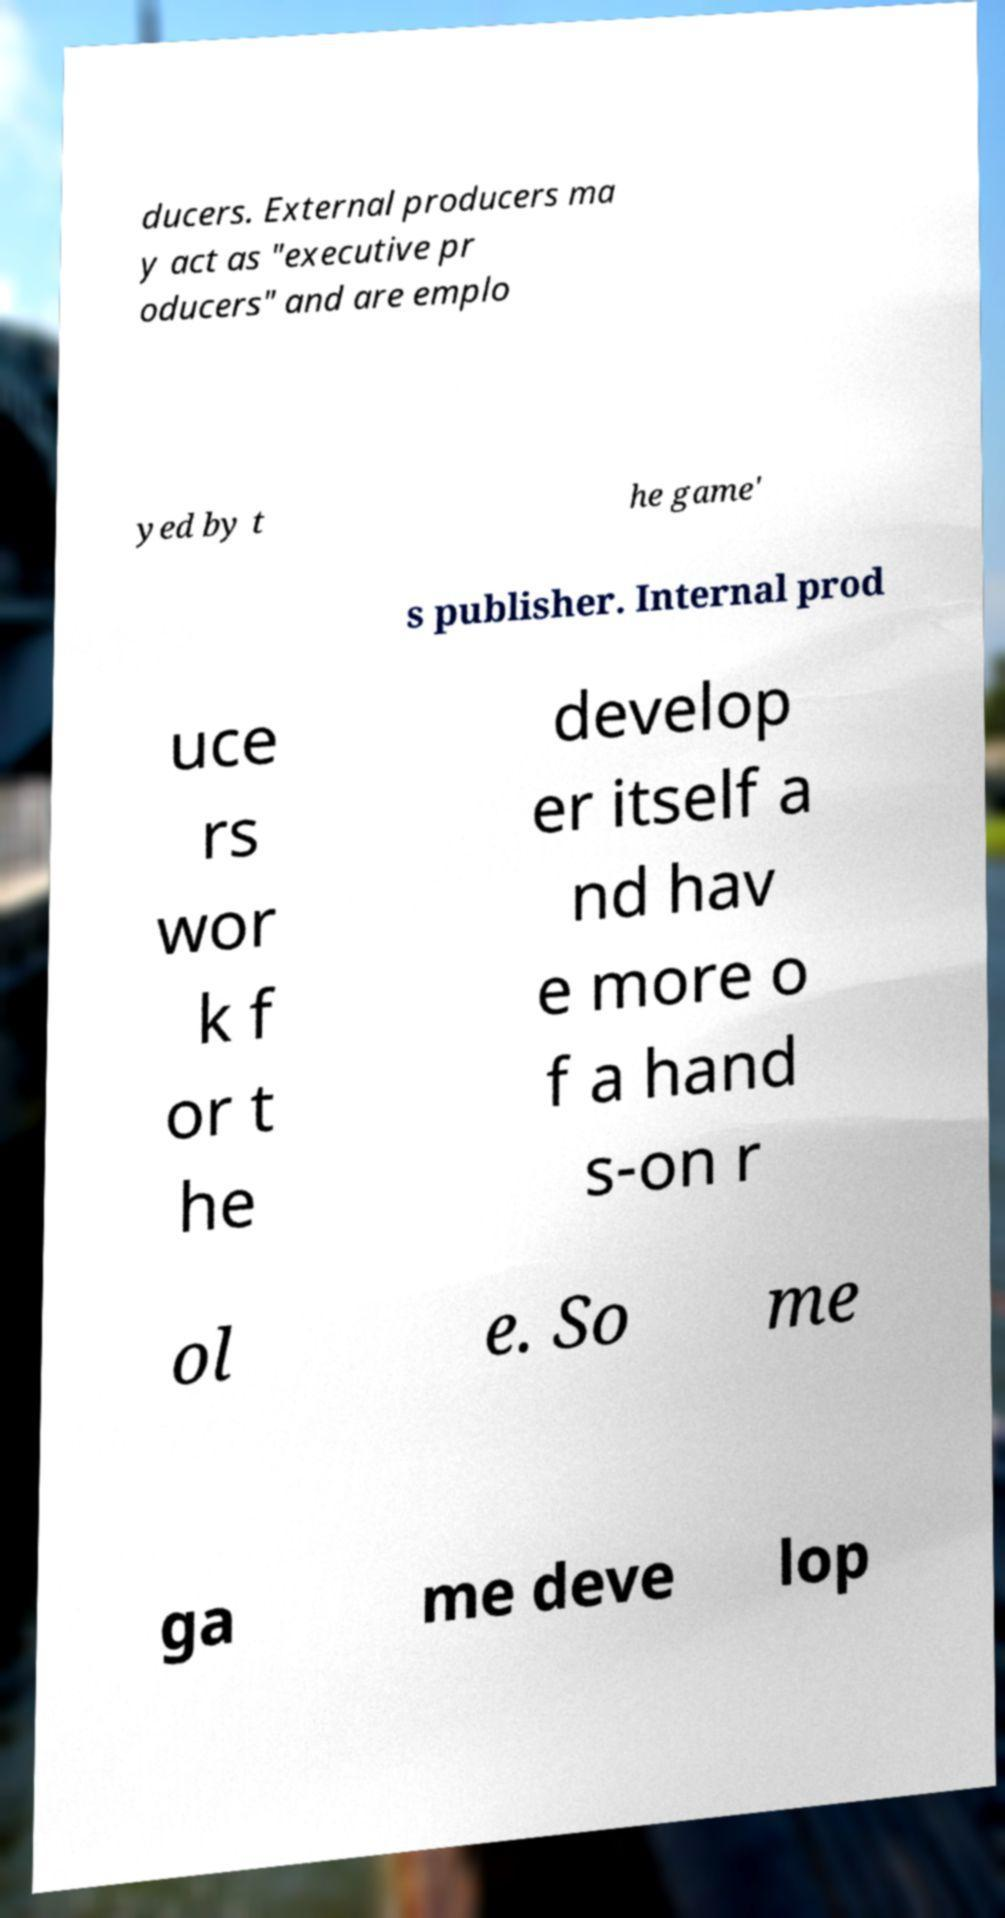Please identify and transcribe the text found in this image. ducers. External producers ma y act as "executive pr oducers" and are emplo yed by t he game' s publisher. Internal prod uce rs wor k f or t he develop er itself a nd hav e more o f a hand s-on r ol e. So me ga me deve lop 